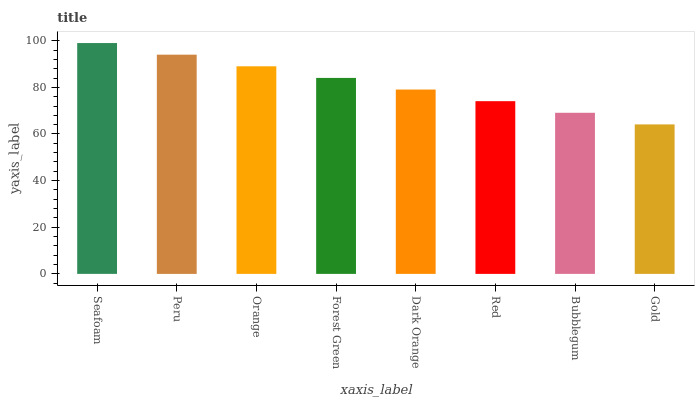Is Gold the minimum?
Answer yes or no. Yes. Is Seafoam the maximum?
Answer yes or no. Yes. Is Peru the minimum?
Answer yes or no. No. Is Peru the maximum?
Answer yes or no. No. Is Seafoam greater than Peru?
Answer yes or no. Yes. Is Peru less than Seafoam?
Answer yes or no. Yes. Is Peru greater than Seafoam?
Answer yes or no. No. Is Seafoam less than Peru?
Answer yes or no. No. Is Forest Green the high median?
Answer yes or no. Yes. Is Dark Orange the low median?
Answer yes or no. Yes. Is Orange the high median?
Answer yes or no. No. Is Orange the low median?
Answer yes or no. No. 